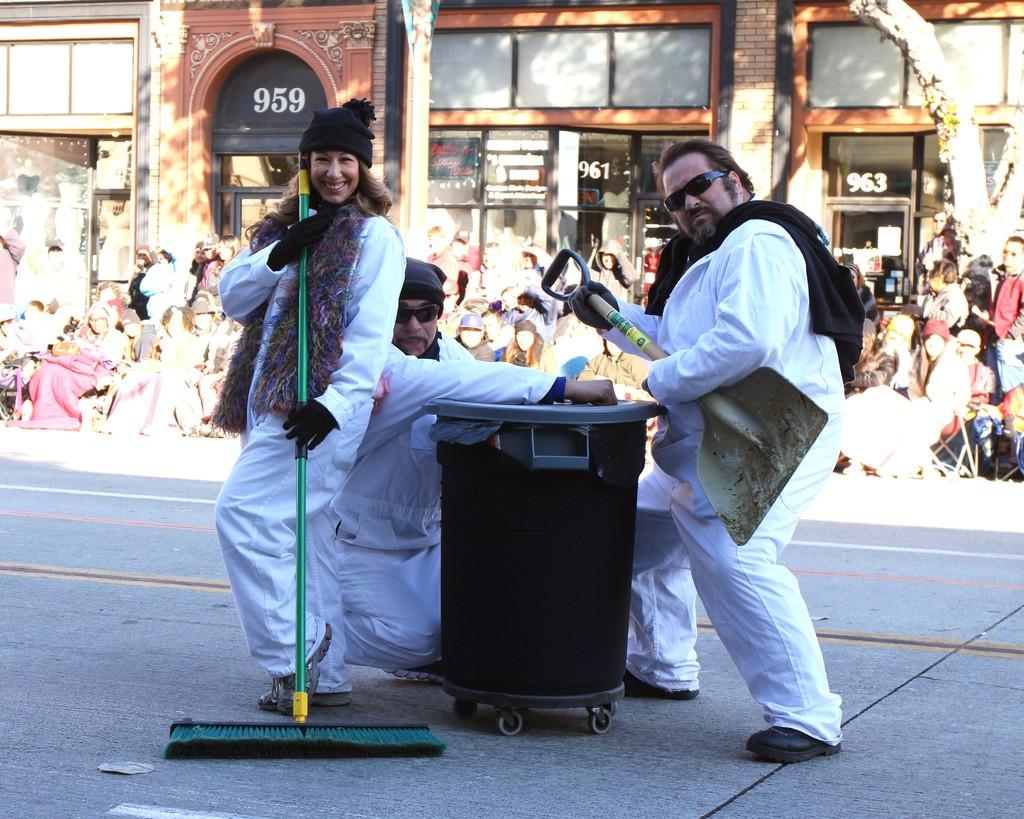What is the building number in the middle?
Provide a succinct answer. 961. What is the building number on the left?
Your response must be concise. 959. 